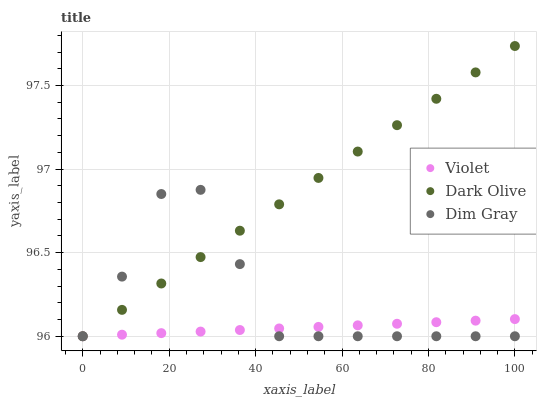Does Violet have the minimum area under the curve?
Answer yes or no. Yes. Does Dark Olive have the maximum area under the curve?
Answer yes or no. Yes. Does Dark Olive have the minimum area under the curve?
Answer yes or no. No. Does Violet have the maximum area under the curve?
Answer yes or no. No. Is Dark Olive the smoothest?
Answer yes or no. Yes. Is Dim Gray the roughest?
Answer yes or no. Yes. Is Violet the smoothest?
Answer yes or no. No. Is Violet the roughest?
Answer yes or no. No. Does Dim Gray have the lowest value?
Answer yes or no. Yes. Does Dark Olive have the highest value?
Answer yes or no. Yes. Does Violet have the highest value?
Answer yes or no. No. Does Dim Gray intersect Dark Olive?
Answer yes or no. Yes. Is Dim Gray less than Dark Olive?
Answer yes or no. No. Is Dim Gray greater than Dark Olive?
Answer yes or no. No. 